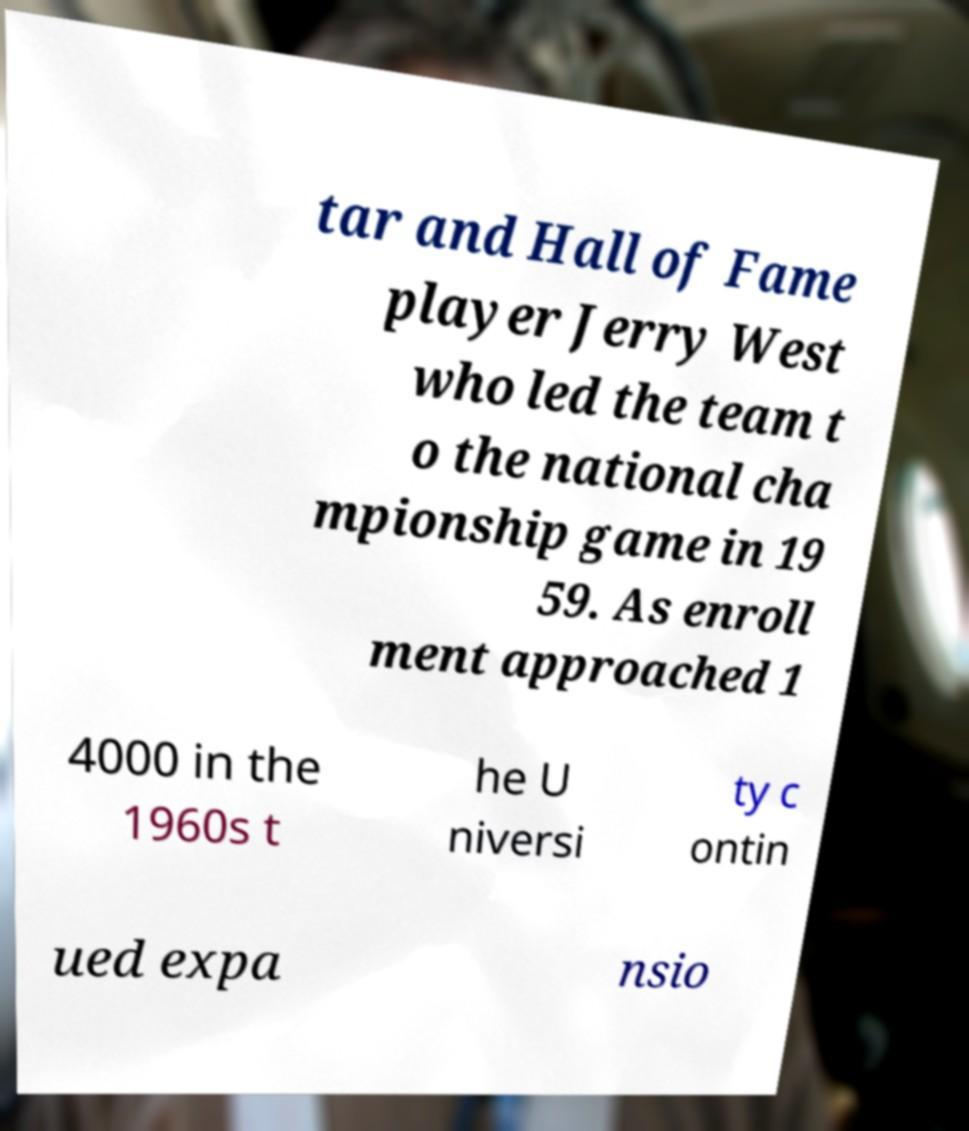Please read and relay the text visible in this image. What does it say? tar and Hall of Fame player Jerry West who led the team t o the national cha mpionship game in 19 59. As enroll ment approached 1 4000 in the 1960s t he U niversi ty c ontin ued expa nsio 